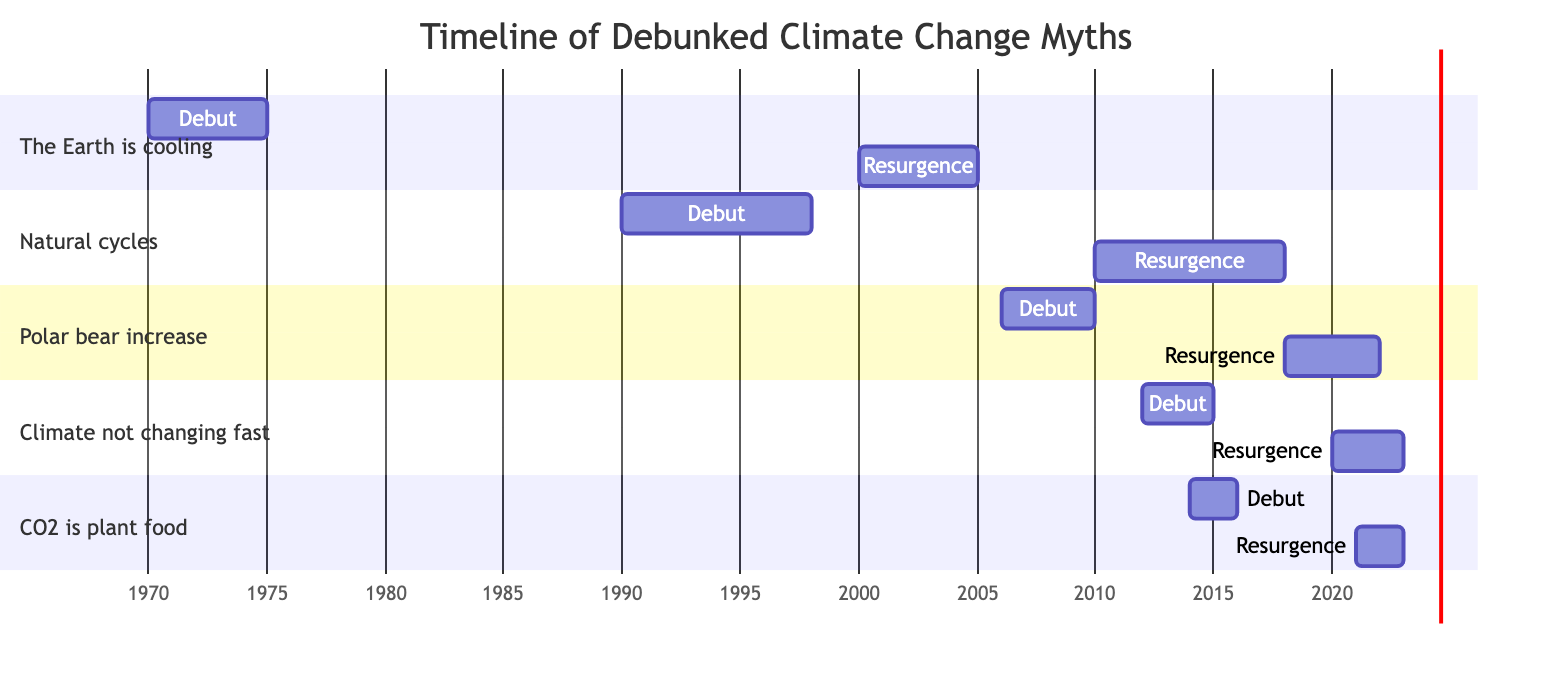What is the debut year of the myth "CO2 is plant food and isn't harmful"? In the diagram, we locate the section for "CO2 is plant food and isn't harmful" and observe the year indicated next to "Debut," which is 2014.
Answer: 2014 What is the duration of the myth "The Earth is cooling"? By examining the section labeled "The Earth is cooling," we see the duration listed next to it, which indicates how many years this myth was prevalent, noted as 5 years.
Answer: 5 Which myth had its debut in 1990? Looking at the diagram, we find the section that begins with the year 1990, indicating the myth that debuted then is "Climate change is caused by natural cycles."
Answer: Climate change is caused by natural cycles How many myths had a resurgence in 2021? To answer this, we review the diagram for all sections and locate any resurgence years marked 2021. We see that there is one myth, which is "CO2 is plant food and isn't harmful."
Answer: 1 What is the time span between the debut and resurgence of the myth "Polar bear populations are increasing"? In the section for "Polar bear populations are increasing," we notice that the debut year is 2006 and the resurgence year is 2018. The difference in these years is 12 years, indicating the time span between these events.
Answer: 12 years Which myth had the longest duration before its resurgence? We need to analyze all myths' durations from the diagram and compare them. The myth with the longest duration before its resurgence is "Climate change is caused by natural cycles," which lasted 8 years.
Answer: Climate change is caused by natural cycles What is the earliest debut year shown in the diagram? By scanning through all the debut years listed in the sections of the diagram, the earliest year is found in "The Earth is cooling," which debuts in 1970.
Answer: 1970 How many sections are there in the Gantt chart? By counting the distinct sections listed in the diagram, we find that there are five sections, each representing a different myth.
Answer: 5 Which myth had a resurgence in 2020? Looking through the diagram, we identify that the myth labeled "Climate is not changing as fast as scientists claim" had its resurgence year listed as 2020.
Answer: Climate is not changing as fast as scientists claim 